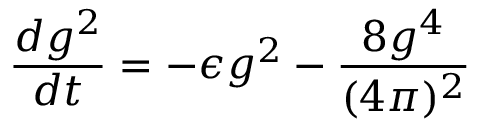Convert formula to latex. <formula><loc_0><loc_0><loc_500><loc_500>\frac { d g ^ { 2 } } { d t } = - \epsilon g ^ { 2 } - \frac { 8 g ^ { 4 } } { ( 4 \pi ) ^ { 2 } }</formula> 